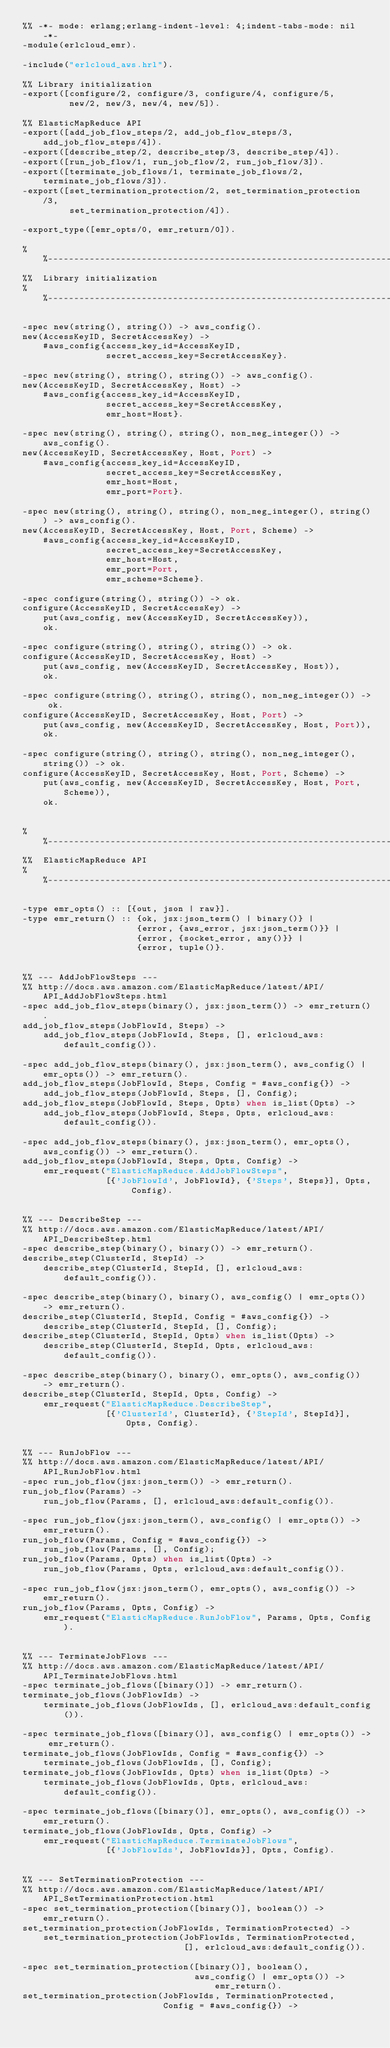Convert code to text. <code><loc_0><loc_0><loc_500><loc_500><_Erlang_>%% -*- mode: erlang;erlang-indent-level: 4;indent-tabs-mode: nil -*-
-module(erlcloud_emr).

-include("erlcloud_aws.hrl").

%% Library initialization
-export([configure/2, configure/3, configure/4, configure/5,
         new/2, new/3, new/4, new/5]).

%% ElasticMapReduce API
-export([add_job_flow_steps/2, add_job_flow_steps/3, add_job_flow_steps/4]).
-export([describe_step/2, describe_step/3, describe_step/4]).
-export([run_job_flow/1, run_job_flow/2, run_job_flow/3]).
-export([terminate_job_flows/1, terminate_job_flows/2, terminate_job_flows/3]).
-export([set_termination_protection/2, set_termination_protection/3,
         set_termination_protection/4]).

-export_type([emr_opts/0, emr_return/0]).

%%------------------------------------------------------------------------------
%%  Library initialization
%%------------------------------------------------------------------------------

-spec new(string(), string()) -> aws_config().
new(AccessKeyID, SecretAccessKey) ->
    #aws_config{access_key_id=AccessKeyID,
                secret_access_key=SecretAccessKey}.

-spec new(string(), string(), string()) -> aws_config().
new(AccessKeyID, SecretAccessKey, Host) ->
    #aws_config{access_key_id=AccessKeyID,
                secret_access_key=SecretAccessKey,
                emr_host=Host}.

-spec new(string(), string(), string(), non_neg_integer()) -> aws_config().
new(AccessKeyID, SecretAccessKey, Host, Port) ->
    #aws_config{access_key_id=AccessKeyID,
                secret_access_key=SecretAccessKey,
                emr_host=Host,
                emr_port=Port}.

-spec new(string(), string(), string(), non_neg_integer(), string()) -> aws_config().
new(AccessKeyID, SecretAccessKey, Host, Port, Scheme) ->
    #aws_config{access_key_id=AccessKeyID,
                secret_access_key=SecretAccessKey,
                emr_host=Host,
                emr_port=Port,
                emr_scheme=Scheme}.

-spec configure(string(), string()) -> ok.
configure(AccessKeyID, SecretAccessKey) ->
    put(aws_config, new(AccessKeyID, SecretAccessKey)),
    ok.

-spec configure(string(), string(), string()) -> ok.
configure(AccessKeyID, SecretAccessKey, Host) ->
    put(aws_config, new(AccessKeyID, SecretAccessKey, Host)),
    ok.

-spec configure(string(), string(), string(), non_neg_integer()) -> ok.
configure(AccessKeyID, SecretAccessKey, Host, Port) ->
    put(aws_config, new(AccessKeyID, SecretAccessKey, Host, Port)),
    ok.

-spec configure(string(), string(), string(), non_neg_integer(), string()) -> ok.
configure(AccessKeyID, SecretAccessKey, Host, Port, Scheme) ->
    put(aws_config, new(AccessKeyID, SecretAccessKey, Host, Port, Scheme)),
    ok.


%%------------------------------------------------------------------------------
%%  ElasticMapReduce API
%%------------------------------------------------------------------------------

-type emr_opts() :: [{out, json | raw}].
-type emr_return() :: {ok, jsx:json_term() | binary()} |
                      {error, {aws_error, jsx:json_term()}} |
                      {error, {socket_error, any()}} |
                      {error, tuple()}.


%% --- AddJobFlowSteps ---
%% http://docs.aws.amazon.com/ElasticMapReduce/latest/API/API_AddJobFlowSteps.html
-spec add_job_flow_steps(binary(), jsx:json_term()) -> emr_return().
add_job_flow_steps(JobFlowId, Steps) ->
    add_job_flow_steps(JobFlowId, Steps, [], erlcloud_aws:default_config()).

-spec add_job_flow_steps(binary(), jsx:json_term(), aws_config() | emr_opts()) -> emr_return().
add_job_flow_steps(JobFlowId, Steps, Config = #aws_config{}) ->
    add_job_flow_steps(JobFlowId, Steps, [], Config);
add_job_flow_steps(JobFlowId, Steps, Opts) when is_list(Opts) ->
    add_job_flow_steps(JobFlowId, Steps, Opts, erlcloud_aws:default_config()).

-spec add_job_flow_steps(binary(), jsx:json_term(), emr_opts(), aws_config()) -> emr_return().
add_job_flow_steps(JobFlowId, Steps, Opts, Config) ->
    emr_request("ElasticMapReduce.AddJobFlowSteps",
                [{'JobFlowId', JobFlowId}, {'Steps', Steps}], Opts, Config).


%% --- DescribeStep ---
%% http://docs.aws.amazon.com/ElasticMapReduce/latest/API/API_DescribeStep.html
-spec describe_step(binary(), binary()) -> emr_return().
describe_step(ClusterId, StepId) ->
    describe_step(ClusterId, StepId, [], erlcloud_aws:default_config()).

-spec describe_step(binary(), binary(), aws_config() | emr_opts()) -> emr_return().
describe_step(ClusterId, StepId, Config = #aws_config{}) ->
    describe_step(ClusterId, StepId, [], Config);
describe_step(ClusterId, StepId, Opts) when is_list(Opts) ->
    describe_step(ClusterId, StepId, Opts, erlcloud_aws:default_config()).

-spec describe_step(binary(), binary(), emr_opts(), aws_config()) -> emr_return().
describe_step(ClusterId, StepId, Opts, Config) ->
    emr_request("ElasticMapReduce.DescribeStep",
                [{'ClusterId', ClusterId}, {'StepId', StepId}], Opts, Config).


%% --- RunJobFlow ---
%% http://docs.aws.amazon.com/ElasticMapReduce/latest/API/API_RunJobFlow.html
-spec run_job_flow(jsx:json_term()) -> emr_return().
run_job_flow(Params) ->
    run_job_flow(Params, [], erlcloud_aws:default_config()).

-spec run_job_flow(jsx:json_term(), aws_config() | emr_opts()) -> emr_return().
run_job_flow(Params, Config = #aws_config{}) ->
    run_job_flow(Params, [], Config);
run_job_flow(Params, Opts) when is_list(Opts) ->
    run_job_flow(Params, Opts, erlcloud_aws:default_config()).

-spec run_job_flow(jsx:json_term(), emr_opts(), aws_config()) -> emr_return().
run_job_flow(Params, Opts, Config) ->
    emr_request("ElasticMapReduce.RunJobFlow", Params, Opts, Config).


%% --- TerminateJobFlows ---
%% http://docs.aws.amazon.com/ElasticMapReduce/latest/API/API_TerminateJobFlows.html
-spec terminate_job_flows([binary()]) -> emr_return().
terminate_job_flows(JobFlowIds) ->
    terminate_job_flows(JobFlowIds, [], erlcloud_aws:default_config()).

-spec terminate_job_flows([binary()], aws_config() | emr_opts()) -> emr_return().
terminate_job_flows(JobFlowIds, Config = #aws_config{}) ->
    terminate_job_flows(JobFlowIds, [], Config);
terminate_job_flows(JobFlowIds, Opts) when is_list(Opts) ->
    terminate_job_flows(JobFlowIds, Opts, erlcloud_aws:default_config()).

-spec terminate_job_flows([binary()], emr_opts(), aws_config()) -> emr_return().
terminate_job_flows(JobFlowIds, Opts, Config) ->
    emr_request("ElasticMapReduce.TerminateJobFlows",
                [{'JobFlowIds', JobFlowIds}], Opts, Config).


%% --- SetTerminationProtection ---
%% http://docs.aws.amazon.com/ElasticMapReduce/latest/API/API_SetTerminationProtection.html
-spec set_termination_protection([binary()], boolean()) -> emr_return().
set_termination_protection(JobFlowIds, TerminationProtected) ->
    set_termination_protection(JobFlowIds, TerminationProtected,
                               [], erlcloud_aws:default_config()).

-spec set_termination_protection([binary()], boolean(),
                                 aws_config() | emr_opts()) -> emr_return().
set_termination_protection(JobFlowIds, TerminationProtected,
                           Config = #aws_config{}) -></code> 